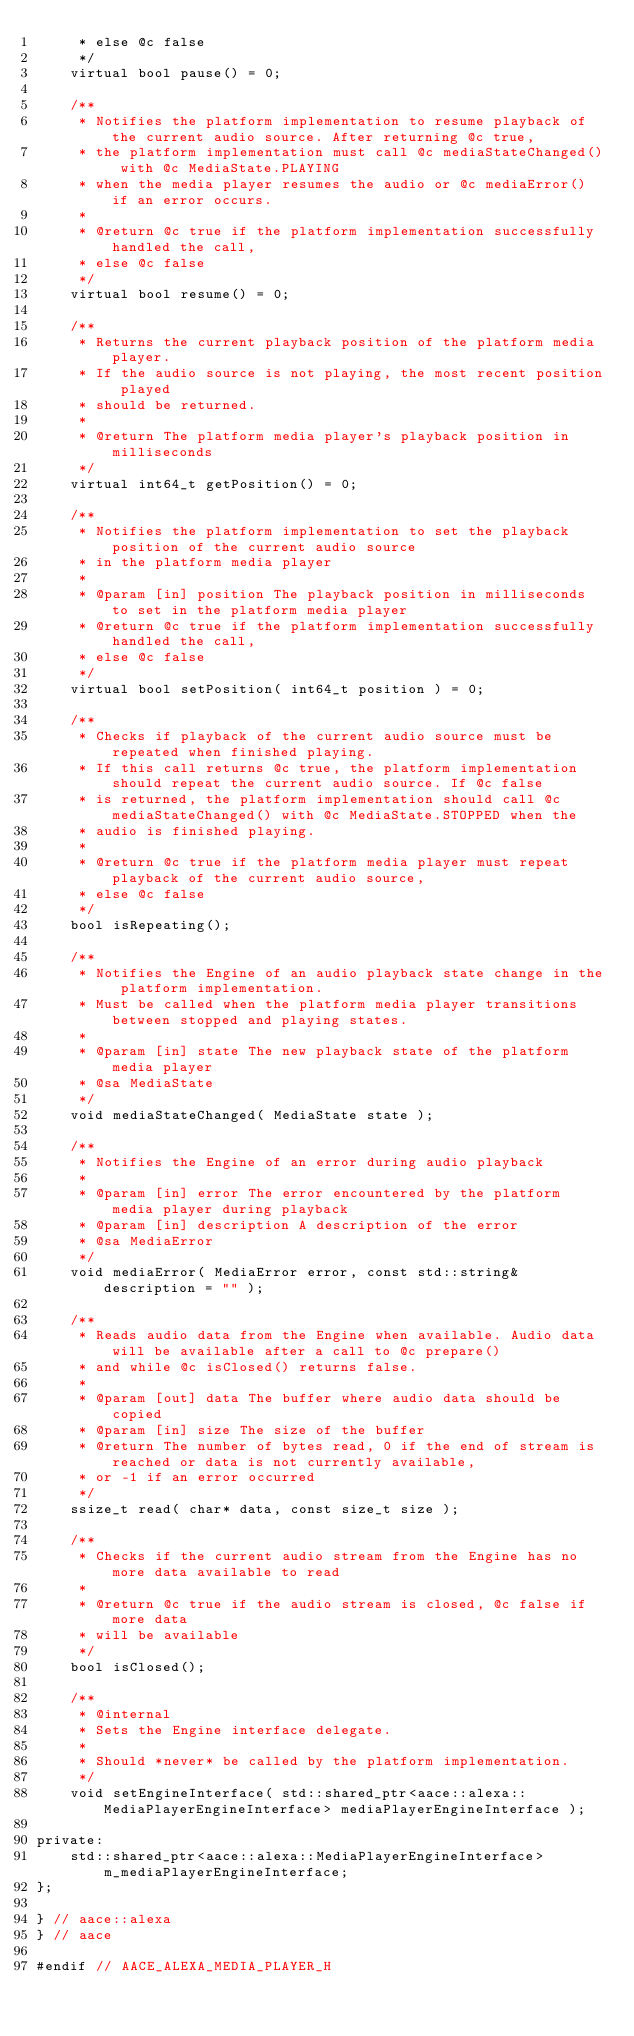<code> <loc_0><loc_0><loc_500><loc_500><_C_>     * else @c false
     */
    virtual bool pause() = 0;

    /**
     * Notifies the platform implementation to resume playback of the current audio source. After returning @c true,
     * the platform implementation must call @c mediaStateChanged() with @c MediaState.PLAYING
     * when the media player resumes the audio or @c mediaError() if an error occurs.
     *
     * @return @c true if the platform implementation successfully handled the call, 
     * else @c false
     */
    virtual bool resume() = 0;

    /**
     * Returns the current playback position of the platform media player.
     * If the audio source is not playing, the most recent position played
     * should be returned.
     *
     * @return The platform media player's playback position in milliseconds
     */
    virtual int64_t getPosition() = 0;

    /**
     * Notifies the platform implementation to set the playback position of the current audio source
     * in the platform media player
     *
     * @param [in] position The playback position in milliseconds to set in the platform media player
     * @return @c true if the platform implementation successfully handled the call, 
     * else @c false
     */
    virtual bool setPosition( int64_t position ) = 0;

    /**
     * Checks if playback of the current audio source must be repeated when finished playing.
     * If this call returns @c true, the platform implementation should repeat the current audio source. If @c false
     * is returned, the platform implementation should call @c mediaStateChanged() with @c MediaState.STOPPED when the
     * audio is finished playing.
     *
     * @return @c true if the platform media player must repeat playback of the current audio source,
     * else @c false
     */
    bool isRepeating();
    
    /**
     * Notifies the Engine of an audio playback state change in the platform implementation.
     * Must be called when the platform media player transitions between stopped and playing states.
     *
     * @param [in] state The new playback state of the platform media player
     * @sa MediaState
     */
    void mediaStateChanged( MediaState state );
    
    /**
     * Notifies the Engine of an error during audio playback
     *
     * @param [in] error The error encountered by the platform media player during playback
     * @param [in] description A description of the error
     * @sa MediaError
     */
    void mediaError( MediaError error, const std::string& description = "" );

    /**
     * Reads audio data from the Engine when available. Audio data will be available after a call to @c prepare()
     * and while @c isClosed() returns false.
     *
     * @param [out] data The buffer where audio data should be copied
     * @param [in] size The size of the buffer
     * @return The number of bytes read, 0 if the end of stream is reached or data is not currently available,
     * or -1 if an error occurred
     */
    ssize_t read( char* data, const size_t size );

    /**
     * Checks if the current audio stream from the Engine has no more data available to read
     *
     * @return @c true if the audio stream is closed, @c false if more data
     * will be available
     */
    bool isClosed();

    /**
     * @internal
     * Sets the Engine interface delegate.
     *
     * Should *never* be called by the platform implementation.
     */
    void setEngineInterface( std::shared_ptr<aace::alexa::MediaPlayerEngineInterface> mediaPlayerEngineInterface );

private:
    std::shared_ptr<aace::alexa::MediaPlayerEngineInterface> m_mediaPlayerEngineInterface;
};

} // aace::alexa
} // aace

#endif // AACE_ALEXA_MEDIA_PLAYER_H
</code> 